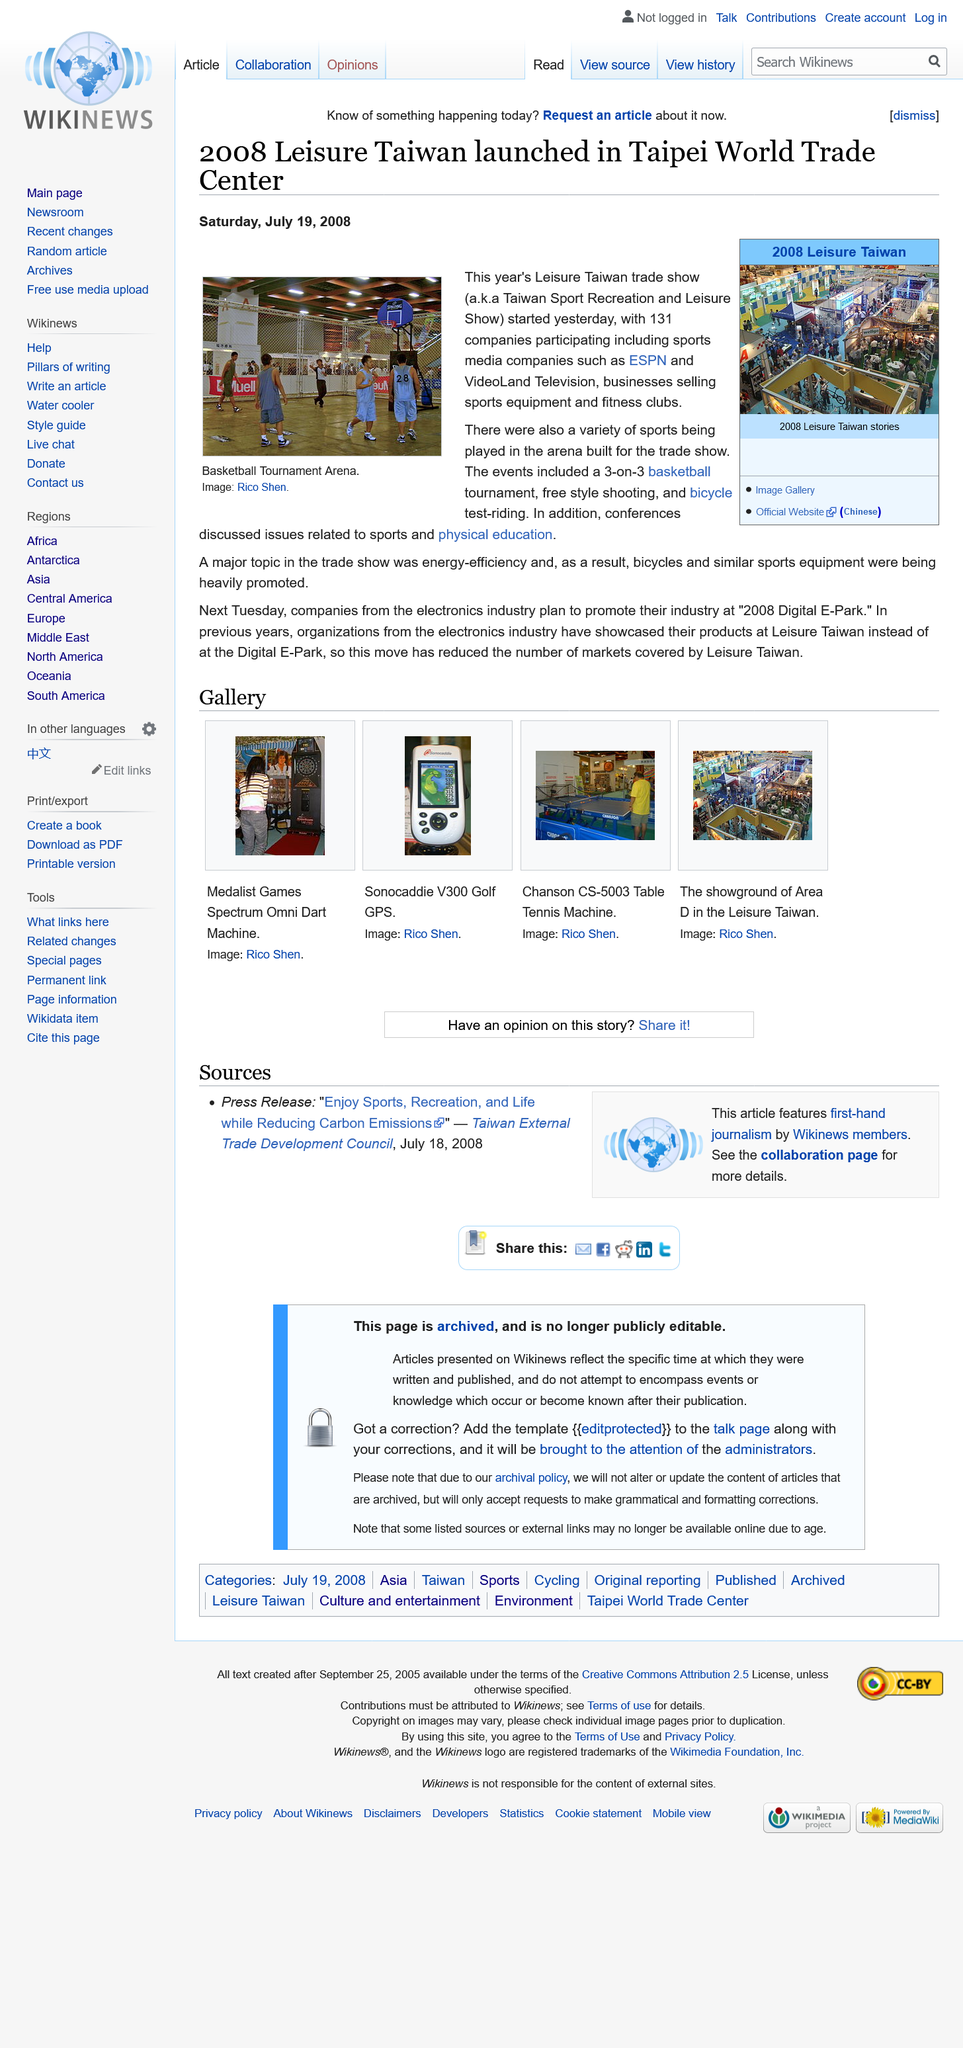Draw attention to some important aspects in this diagram. The Taiwan sports recreation and leisure show began on Friday, July 18th, 2008, and it has been ongoing ever since. During the trade show, the arena was filled with energetic and competitive spirit as a variety of sporting events were held, including a 3 on 3 basketball tournament, freestyle shooting, and bicycle test riding. These events were highly anticipated by visitors, who gathered to witness the athletes' skills and talents. The atmosphere was charged with excitement and cheers as spectators rooted for their favorite participants, while the competitors brought their best performances to secure victory. Overall, the sporting events at the arena added to the vibrant and entertaining experience of the trade show. During the Leisure Taiwan trade show, media companies ESPN and VideoLand Television participated, showcasing their latest offerings in the entertainment industry. 